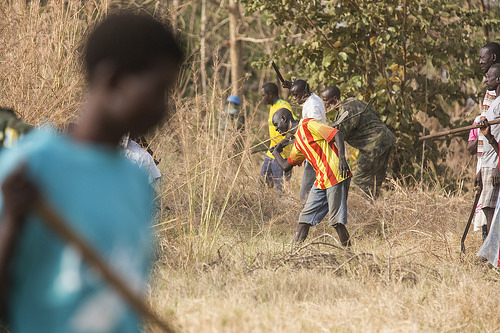<image>
Can you confirm if the man is under the sickle? No. The man is not positioned under the sickle. The vertical relationship between these objects is different. Is there a boy in front of the weeds? Yes. The boy is positioned in front of the weeds, appearing closer to the camera viewpoint. 